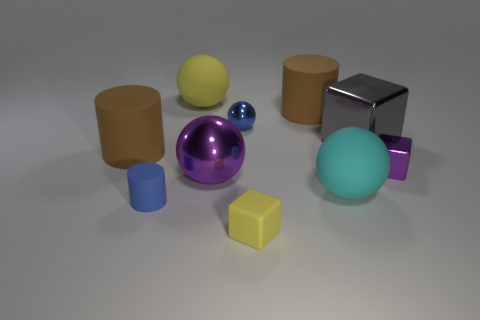How many things are either large gray rubber things or spheres that are behind the large gray cube?
Give a very brief answer. 2. Is the shape of the large rubber object that is on the left side of the large yellow thing the same as the purple thing that is on the right side of the blue sphere?
Ensure brevity in your answer.  No. What number of things are either gray rubber things or big brown cylinders?
Your answer should be compact. 2. Is there any other thing that is made of the same material as the yellow ball?
Your answer should be compact. Yes. Is there a small red shiny thing?
Offer a terse response. No. Do the yellow object on the right side of the big yellow object and the big yellow sphere have the same material?
Ensure brevity in your answer.  Yes. Is there another metallic thing that has the same shape as the tiny yellow object?
Make the answer very short. Yes. Is the number of big objects that are behind the large gray thing the same as the number of big matte things?
Offer a terse response. No. There is a blue thing in front of the purple shiny object to the right of the cyan matte sphere; what is it made of?
Make the answer very short. Rubber. There is a small purple object; what shape is it?
Offer a very short reply. Cube. 